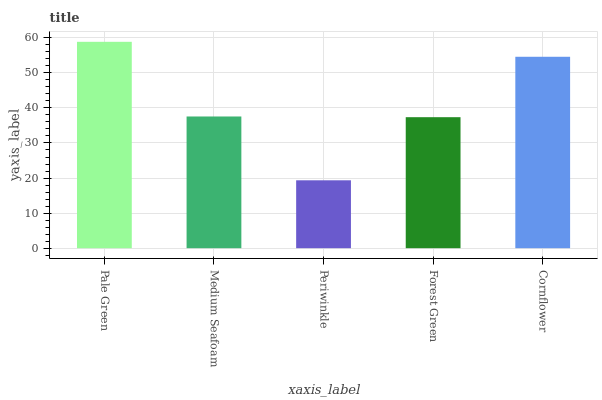Is Periwinkle the minimum?
Answer yes or no. Yes. Is Pale Green the maximum?
Answer yes or no. Yes. Is Medium Seafoam the minimum?
Answer yes or no. No. Is Medium Seafoam the maximum?
Answer yes or no. No. Is Pale Green greater than Medium Seafoam?
Answer yes or no. Yes. Is Medium Seafoam less than Pale Green?
Answer yes or no. Yes. Is Medium Seafoam greater than Pale Green?
Answer yes or no. No. Is Pale Green less than Medium Seafoam?
Answer yes or no. No. Is Medium Seafoam the high median?
Answer yes or no. Yes. Is Medium Seafoam the low median?
Answer yes or no. Yes. Is Pale Green the high median?
Answer yes or no. No. Is Pale Green the low median?
Answer yes or no. No. 